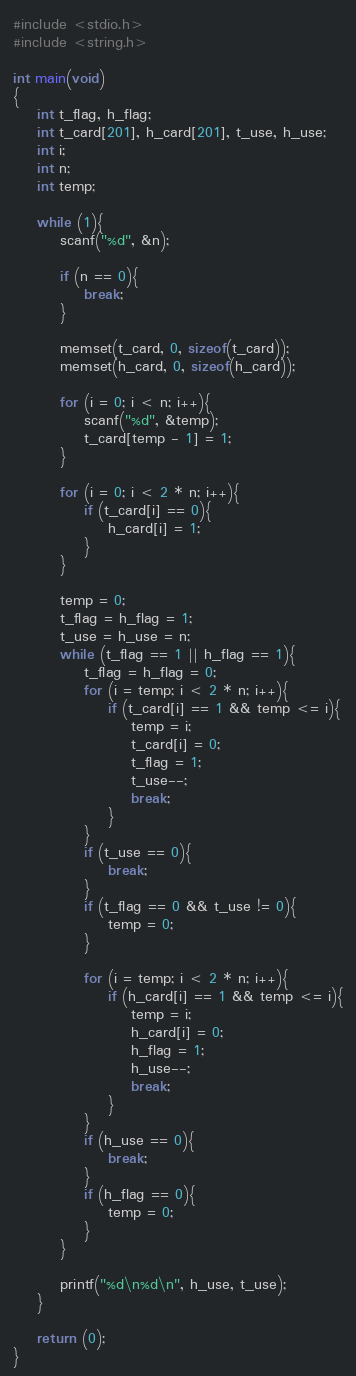Convert code to text. <code><loc_0><loc_0><loc_500><loc_500><_C_>#include <stdio.h>
#include <string.h>

int main(void)
{
    int t_flag, h_flag;
    int t_card[201], h_card[201], t_use, h_use;
    int i;
    int n;
    int temp;
    
    while (1){
        scanf("%d", &n);
        
        if (n == 0){
            break;
        }
        
        memset(t_card, 0, sizeof(t_card));
        memset(h_card, 0, sizeof(h_card));
        
        for (i = 0; i < n; i++){
            scanf("%d", &temp);
            t_card[temp - 1] = 1;
        }
        
        for (i = 0; i < 2 * n; i++){
            if (t_card[i] == 0){
                h_card[i] = 1;
            }
        }
        
        temp = 0;
        t_flag = h_flag = 1;
        t_use = h_use = n;
        while (t_flag == 1 || h_flag == 1){
            t_flag = h_flag = 0;
            for (i = temp; i < 2 * n; i++){
                if (t_card[i] == 1 && temp <= i){
                    temp = i;
                    t_card[i] = 0;
                    t_flag = 1;
                    t_use--;
                    break;
                }
            }
            if (t_use == 0){
                break;
            }
            if (t_flag == 0 && t_use != 0){
                temp = 0;
            }
            
            for (i = temp; i < 2 * n; i++){
                if (h_card[i] == 1 && temp <= i){
                    temp = i;
                    h_card[i] = 0;
                    h_flag = 1;
                    h_use--;
                    break;
                }
            }
            if (h_use == 0){
                break;
            }
            if (h_flag == 0){
                temp = 0;
            }
        }
        
        printf("%d\n%d\n", h_use, t_use);
    }
    
    return (0);
}</code> 